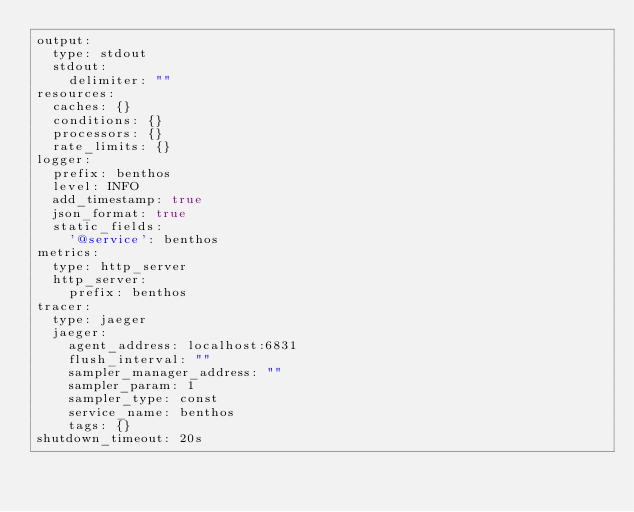<code> <loc_0><loc_0><loc_500><loc_500><_YAML_>output:
  type: stdout
  stdout:
    delimiter: ""
resources:
  caches: {}
  conditions: {}
  processors: {}
  rate_limits: {}
logger:
  prefix: benthos
  level: INFO
  add_timestamp: true
  json_format: true
  static_fields:
    '@service': benthos
metrics:
  type: http_server
  http_server:
    prefix: benthos
tracer:
  type: jaeger
  jaeger:
    agent_address: localhost:6831
    flush_interval: ""
    sampler_manager_address: ""
    sampler_param: 1
    sampler_type: const
    service_name: benthos
    tags: {}
shutdown_timeout: 20s
</code> 